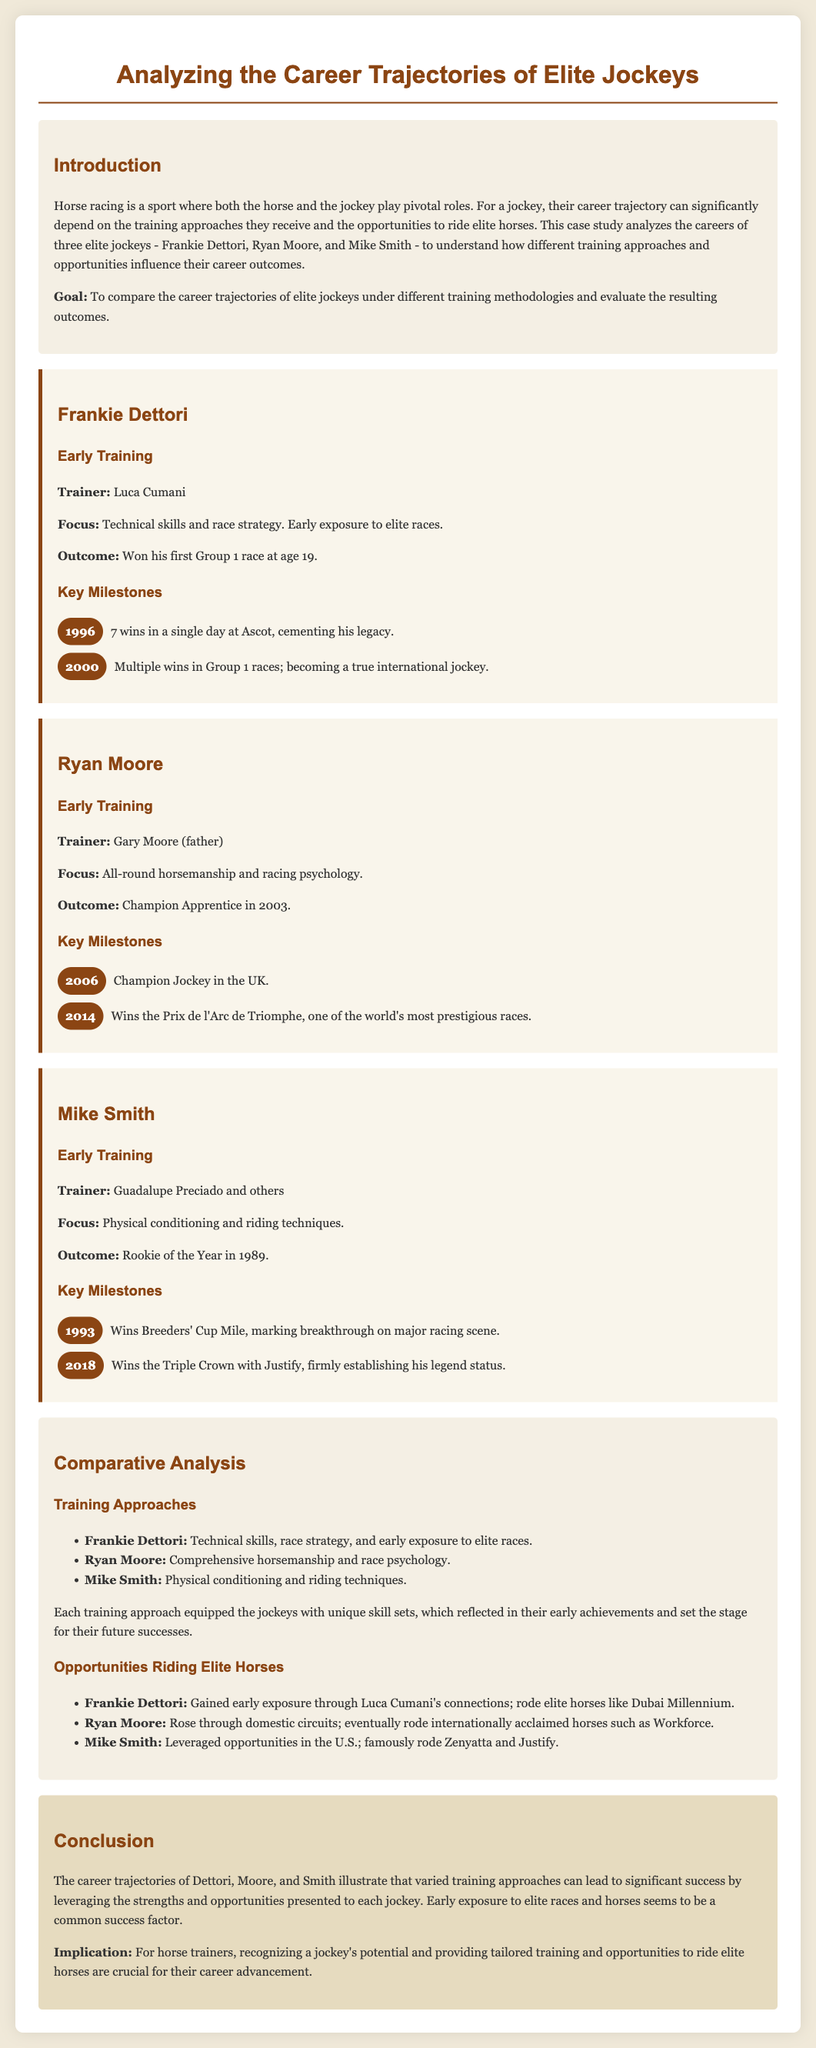What was Frankie Dettori's first major achievement? Frankie Dettori won his first Group 1 race at age 19, which is a significant milestone in his career.
Answer: Won his first Group 1 race at age 19 Who trained Ryan Moore during his early career? Ryan Moore's early training was conducted by his father, which shows the familial connection in his development.
Answer: Gary Moore (father) What year did Mike Smith win the Breeders' Cup Mile? The Breeders' Cup Mile win is a key milestone that took place in 1993, marking an important breakthrough for Mike Smith.
Answer: 1993 What was a common focus in Frankie Dettori's training? The training approach for Frankie Dettori emphasized technical skills and race strategy, which are essential for jockeys to succeed.
Answer: Technical skills and race strategy Which jockey won the Prix de l'Arc de Triomphe? The prestigious race is a highlight in Ryan Moore's career, showcasing his international success as a jockey.
Answer: Ryan Moore What was the outcome of Mike Smith's training focus? Mike Smith's focus on physical conditioning and riding techniques led to him being named Rookie of the Year in 1989.
Answer: Rookie of the Year in 1989 How did early exposure to elite horses impact the jockeys? The document illustrates that gaining early exposure to elite horses played a critical role in the success of these jockeys.
Answer: Common success factor What distinguishes the training approaches of elite jockeys? The different training methods highlight unique strengths and skill sets that each jockey developed through their training.
Answer: Unique skill sets 